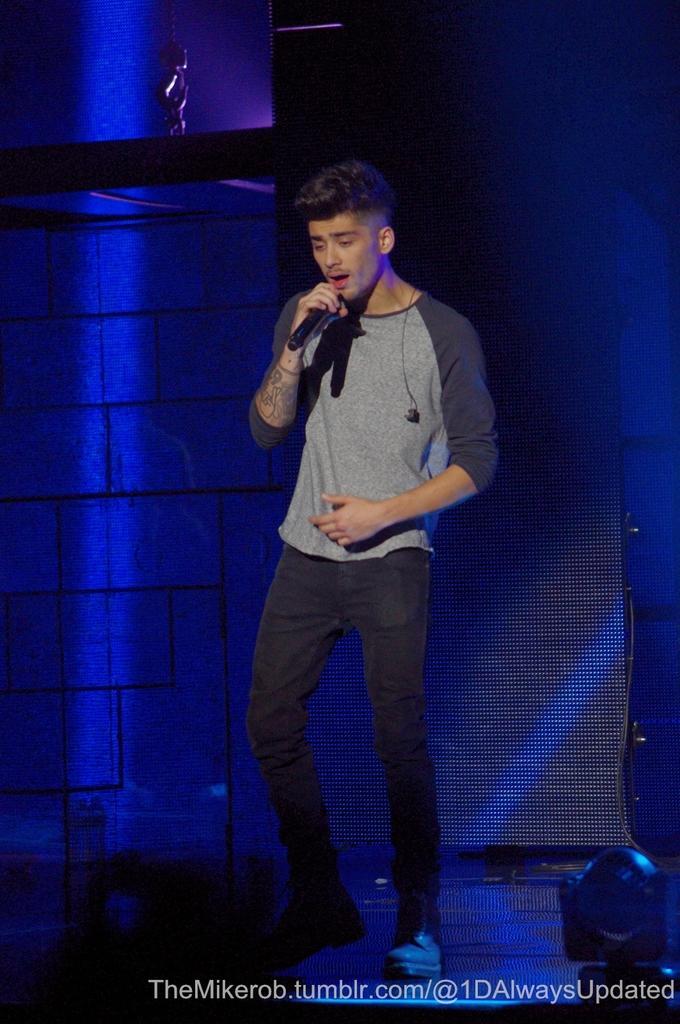Can you describe this image briefly? In the middle of the image a man is standing and holding a microphone. Behind him there is a wall. 